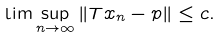Convert formula to latex. <formula><loc_0><loc_0><loc_500><loc_500>\lim \sup _ { n \rightarrow \infty } \left \| T x _ { n } - p \right \| \leq c .</formula> 